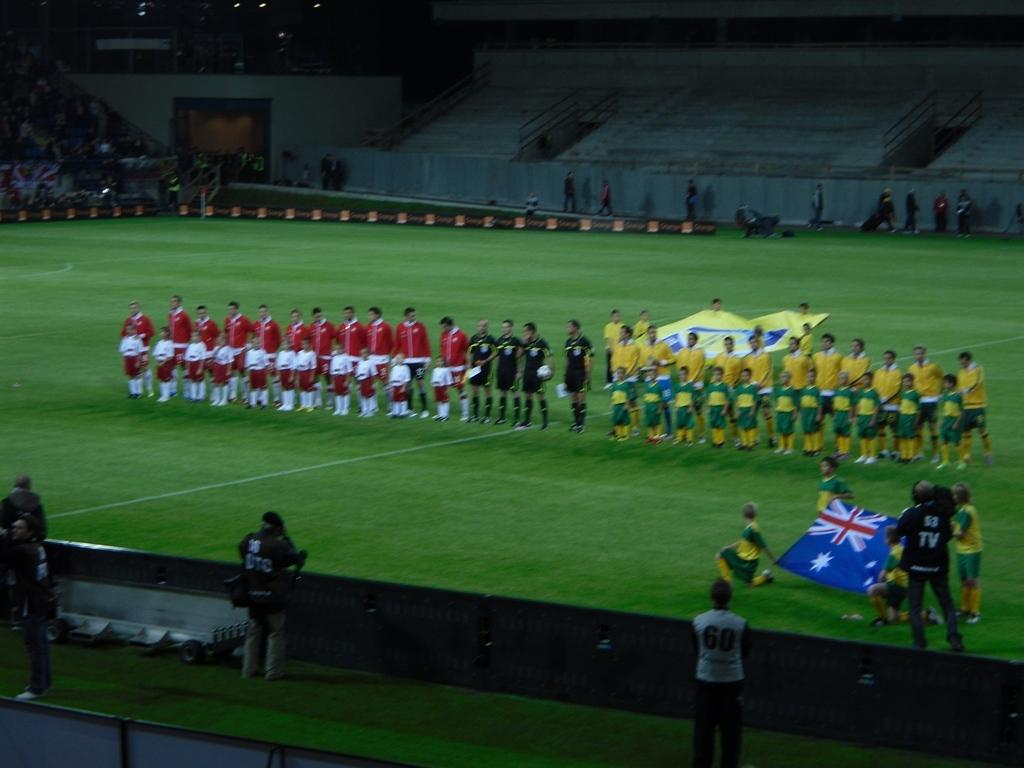<image>
Summarize the visual content of the image. two sports teams on a field with people behind the stands with numbered shirts like 16 and 60 